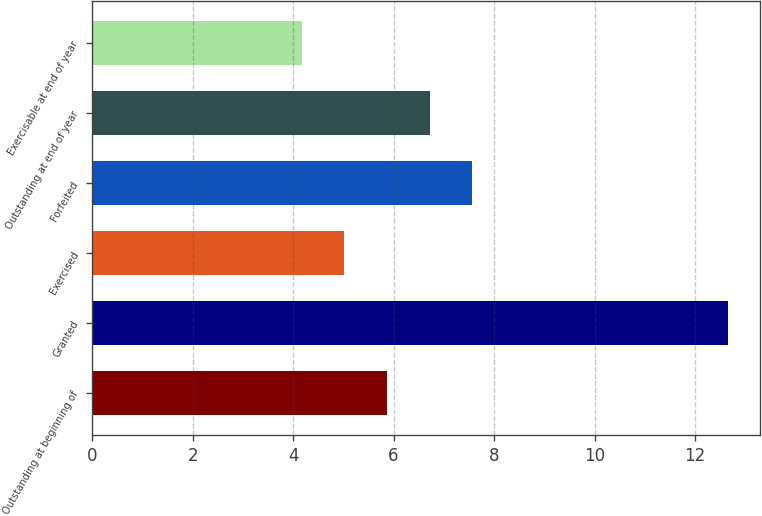<chart> <loc_0><loc_0><loc_500><loc_500><bar_chart><fcel>Outstanding at beginning of<fcel>Granted<fcel>Exercised<fcel>Forfeited<fcel>Outstanding at end of year<fcel>Exercisable at end of year<nl><fcel>5.87<fcel>12.66<fcel>5.02<fcel>7.57<fcel>6.72<fcel>4.17<nl></chart> 